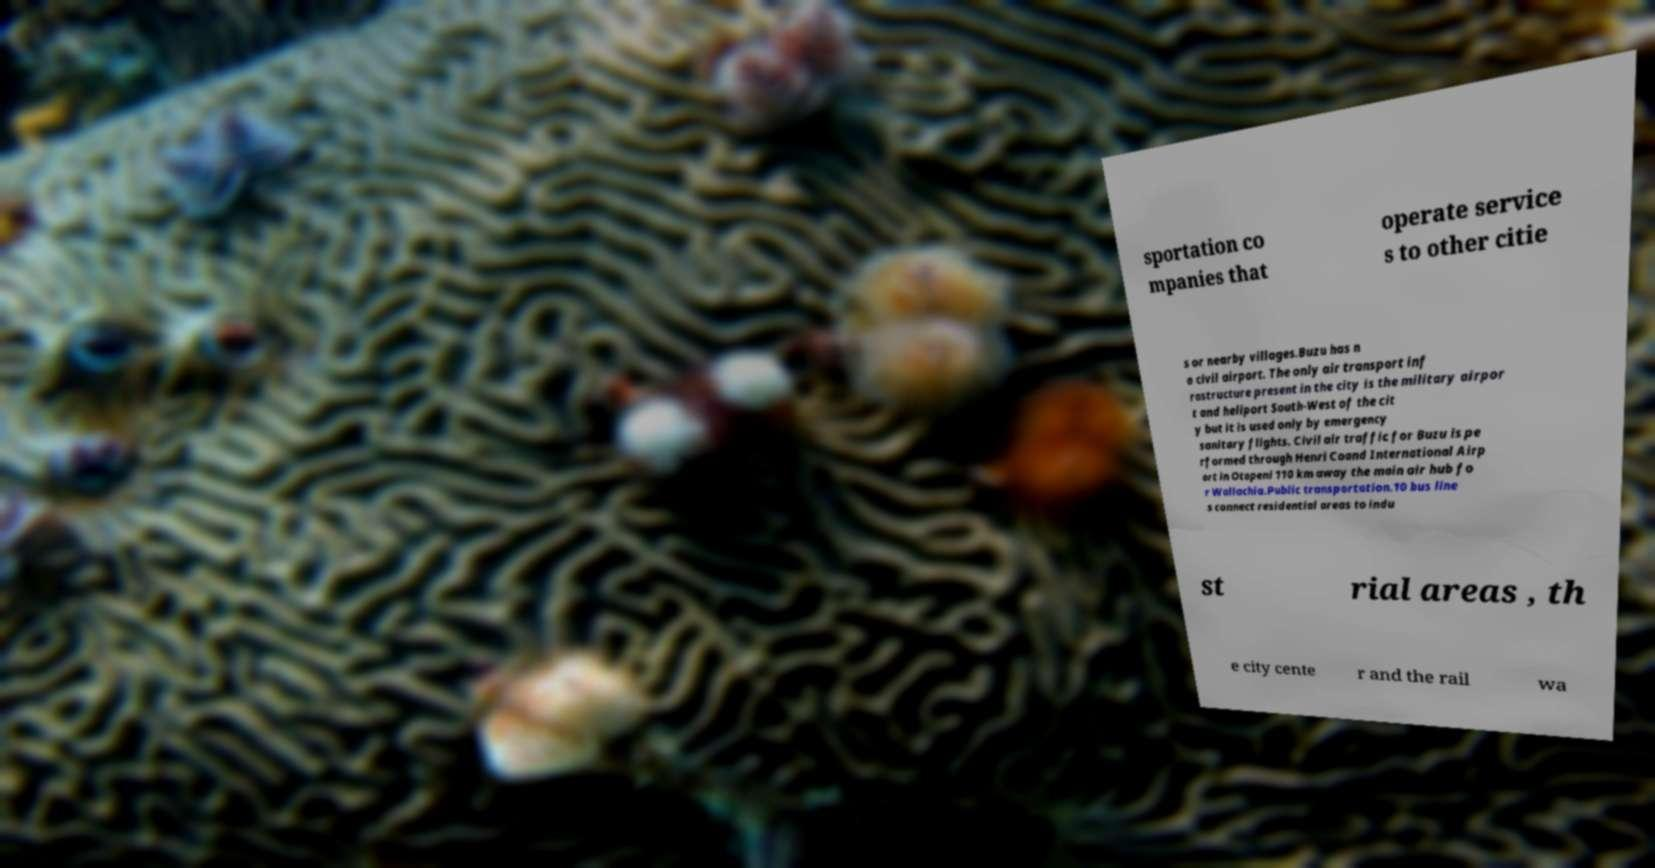I need the written content from this picture converted into text. Can you do that? sportation co mpanies that operate service s to other citie s or nearby villages.Buzu has n o civil airport. The only air transport inf rastructure present in the city is the military airpor t and heliport South-West of the cit y but it is used only by emergency sanitary flights. Civil air traffic for Buzu is pe rformed through Henri Coand International Airp ort in Otopeni 110 km away the main air hub fo r Wallachia.Public transportation.10 bus line s connect residential areas to indu st rial areas , th e city cente r and the rail wa 